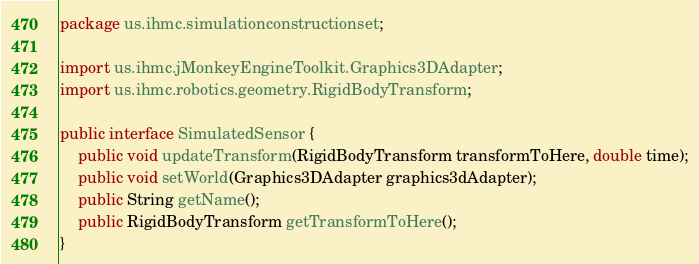Convert code to text. <code><loc_0><loc_0><loc_500><loc_500><_Java_>package us.ihmc.simulationconstructionset;

import us.ihmc.jMonkeyEngineToolkit.Graphics3DAdapter;
import us.ihmc.robotics.geometry.RigidBodyTransform;

public interface SimulatedSensor {
	public void updateTransform(RigidBodyTransform transformToHere, double time);
	public void setWorld(Graphics3DAdapter graphics3dAdapter);
	public String getName();
	public RigidBodyTransform getTransformToHere();
}
</code> 